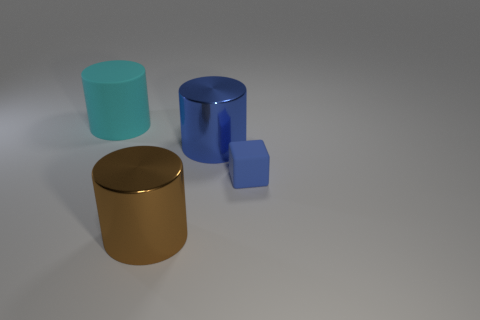How many yellow objects are blocks or large shiny cubes?
Ensure brevity in your answer.  0. Are there the same number of big things on the right side of the small object and tiny matte objects?
Your answer should be compact. No. Are there any other things that are the same size as the blue shiny thing?
Keep it short and to the point. Yes. What is the color of the other metallic thing that is the same shape as the large blue thing?
Make the answer very short. Brown. How many tiny blue matte objects are the same shape as the blue metal object?
Make the answer very short. 0. What is the material of the thing that is the same color as the cube?
Keep it short and to the point. Metal. How many large cyan metallic objects are there?
Make the answer very short. 0. Are there any small red spheres made of the same material as the big blue cylinder?
Provide a short and direct response. No. There is a object that is the same color as the block; what size is it?
Offer a very short reply. Large. There is a matte object on the right side of the brown metallic object; does it have the same size as the thing that is in front of the tiny blue rubber cube?
Keep it short and to the point. No. 